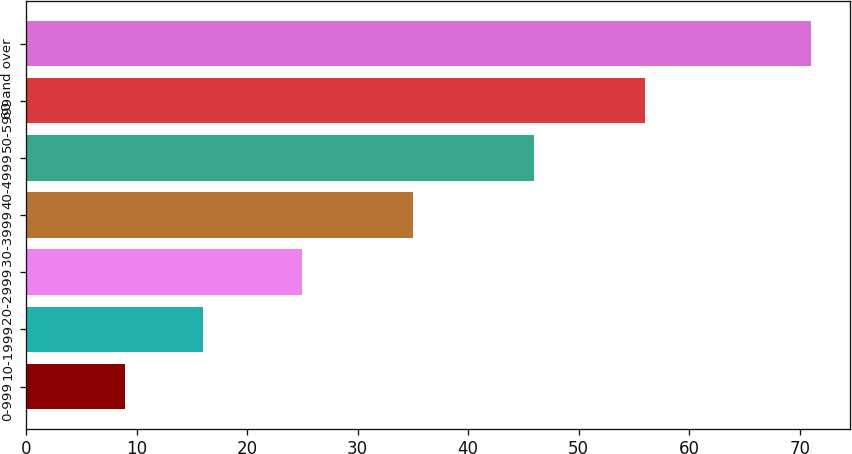<chart> <loc_0><loc_0><loc_500><loc_500><bar_chart><fcel>0-999<fcel>10-1999<fcel>20-2999<fcel>30-3999<fcel>40-4999<fcel>50-5999<fcel>60 and over<nl><fcel>9<fcel>16<fcel>25<fcel>35<fcel>46<fcel>56<fcel>71<nl></chart> 